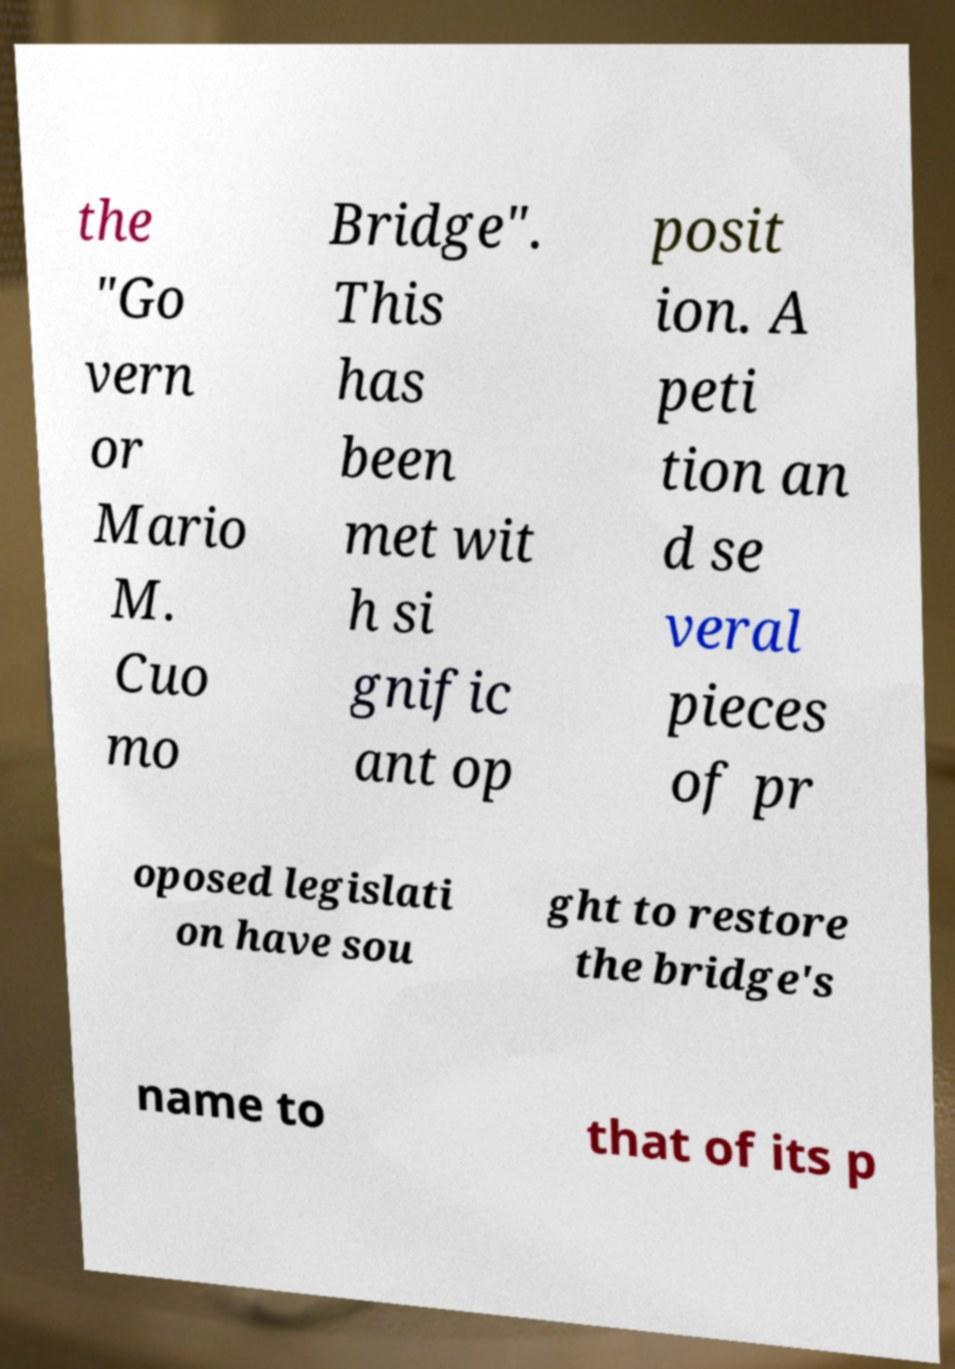Can you accurately transcribe the text from the provided image for me? the "Go vern or Mario M. Cuo mo Bridge". This has been met wit h si gnific ant op posit ion. A peti tion an d se veral pieces of pr oposed legislati on have sou ght to restore the bridge's name to that of its p 